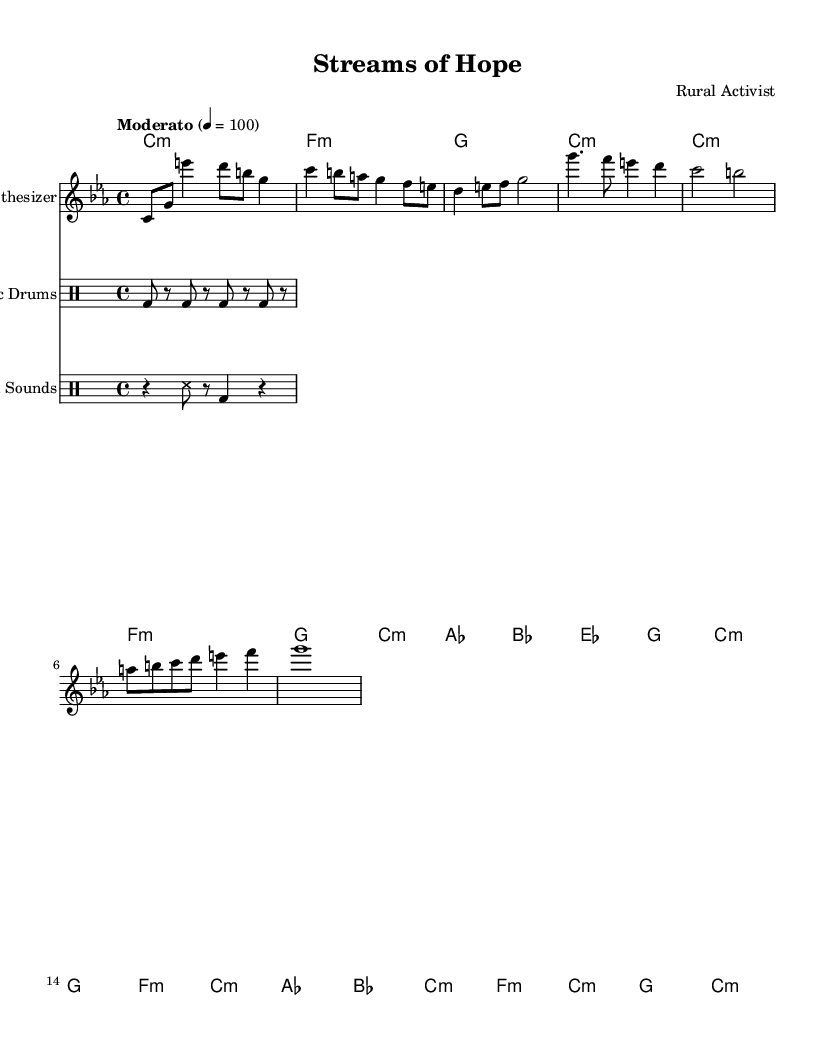What is the key signature of this music? The key signature is C minor, which has three flats (B, E, and A). It is indicated by the absence of sharps and the presence of flats at the beginning of the staff.
Answer: C minor What is the time signature of this piece? The time signature is 4/4, which means there are four beats in a measure and the quarter note gets one beat. This is indicated at the beginning of the score.
Answer: 4/4 What is the tempo marking for this composition? The tempo marking is "Moderato," which indicates a moderate pace. The specific note value for the tempo is also shown as 4 = 100, meaning that there are 100 beats per minute for quarter notes.
Answer: Moderato How many measures are there in the verse section? The verse section consists of three measures, which can be counted from the corresponding notation in the sheet music where the verse starts and ends.
Answer: 3 What instruments are featured in this piece? The featured instruments in this piece include a synthesizer, electronic drums, and sampled farm sounds, each indicated clearly in the staff or drum staff headings.
Answer: Synthesizer, Electronic Drums, Sampled Farm Sounds Which musical section has the longest duration? The bridge section has the longest duration as it contains a whole note (g1), which lasts for four beats and is the only section with such duration. The other sections primarily use shorter note values.
Answer: Bridge What type of electronic sounds are represented in the score? The score represents synthesized sounds from the synthesizer, rhythmic patterns from electronic drums, and recorded or sampled sounds from a farm, all contributing different textural elements typical in experimental music.
Answer: Synthesized, Electronic, Sampled 